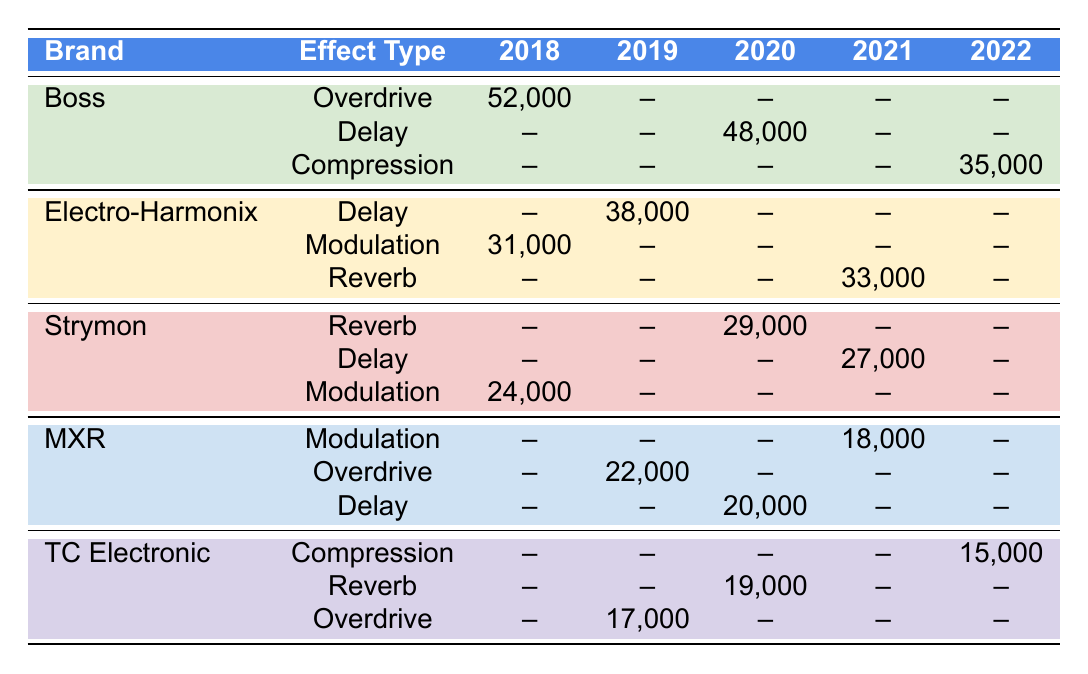What was the highest units sold for a Boss pedal? The highest units sold for a Boss pedal is 52,000 in 2018 for the Overdrive type.
Answer: 52000 Which brand had the lowest sales in 2022? The lowest sales in 2022 is 15,000 units sold by TC Electronic for the Compression type.
Answer: 15000 Is there any effect type that sold more than 50,000 units? Yes, the Overdrive from Boss sold 52,000 units in 2018.
Answer: Yes Which effect type had consistent sales across the years for the brands listed? There is no single effect type that appears consistently with sales across the years for all brands in the table.
Answer: No What was the total number of units sold for Electro-Harmonix from 2018 to 2021? The total is calculated as 31,000 (2018) + 38,000 (2019) + 0 (2020) + 33,000 (2021) = 102,000.
Answer: 102000 What was the trend in Strymon's sales from 2018 to 2021? Strymon had sales of 24,000 in 2018, 0 in 2019, 29,000 in 2020, and 27,000 in 2021, showing an initial rise, then a peak, followed by a slight drop.
Answer: Rising then dropping Did MXR have sales for the Delay effect type in 2021? No, there are no sales recorded for MXR in the Delay effect type for 2021.
Answer: No Which brand had the maximum units sold for the Modulation effect type? Electro-Harmonix sold a total of 31,000 units for Modulation in 2018, which is the highest.
Answer: 31000 How many total units did TC Electronic sell across all effect types in 2020? TC Electronic sold 19,000 (Reverb) + 0 (other types in 2020) = 19,000 units in 2020.
Answer: 19000 What is the difference in units sold between Boss Overdrive in 2018 and TC Electronic Overdrive in 2019? Boss Overdrive sold 52,000 in 2018 and TC Electronic Overdrive sold 17,000 in 2019. The difference is 52,000 - 17,000 = 35,000 units.
Answer: 35000 Which brand's sales show zero units sold for a specific effect type across all years? Strymon shows zero units sold for the Delay effect type in 2018, 2019, and 2020.
Answer: Strymon 